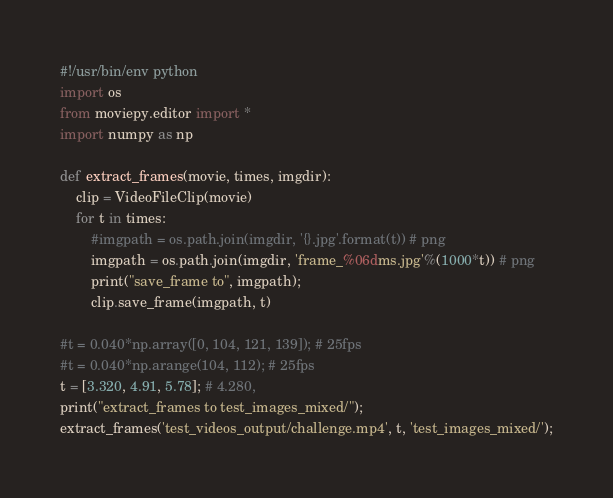<code> <loc_0><loc_0><loc_500><loc_500><_Python_>#!/usr/bin/env python
import os
from moviepy.editor import *
import numpy as np

def extract_frames(movie, times, imgdir):
    clip = VideoFileClip(movie)
    for t in times:
        #imgpath = os.path.join(imgdir, '{}.jpg'.format(t)) # png
        imgpath = os.path.join(imgdir, 'frame_%06dms.jpg'%(1000*t)) # png
        print("save_frame to", imgpath);
        clip.save_frame(imgpath, t)

#t = 0.040*np.array([0, 104, 121, 139]); # 25fps
#t = 0.040*np.arange(104, 112); # 25fps
t = [3.320, 4.91, 5.78]; # 4.280, 
print("extract_frames to test_images_mixed/");
extract_frames('test_videos_output/challenge.mp4', t, 'test_images_mixed/');
</code> 